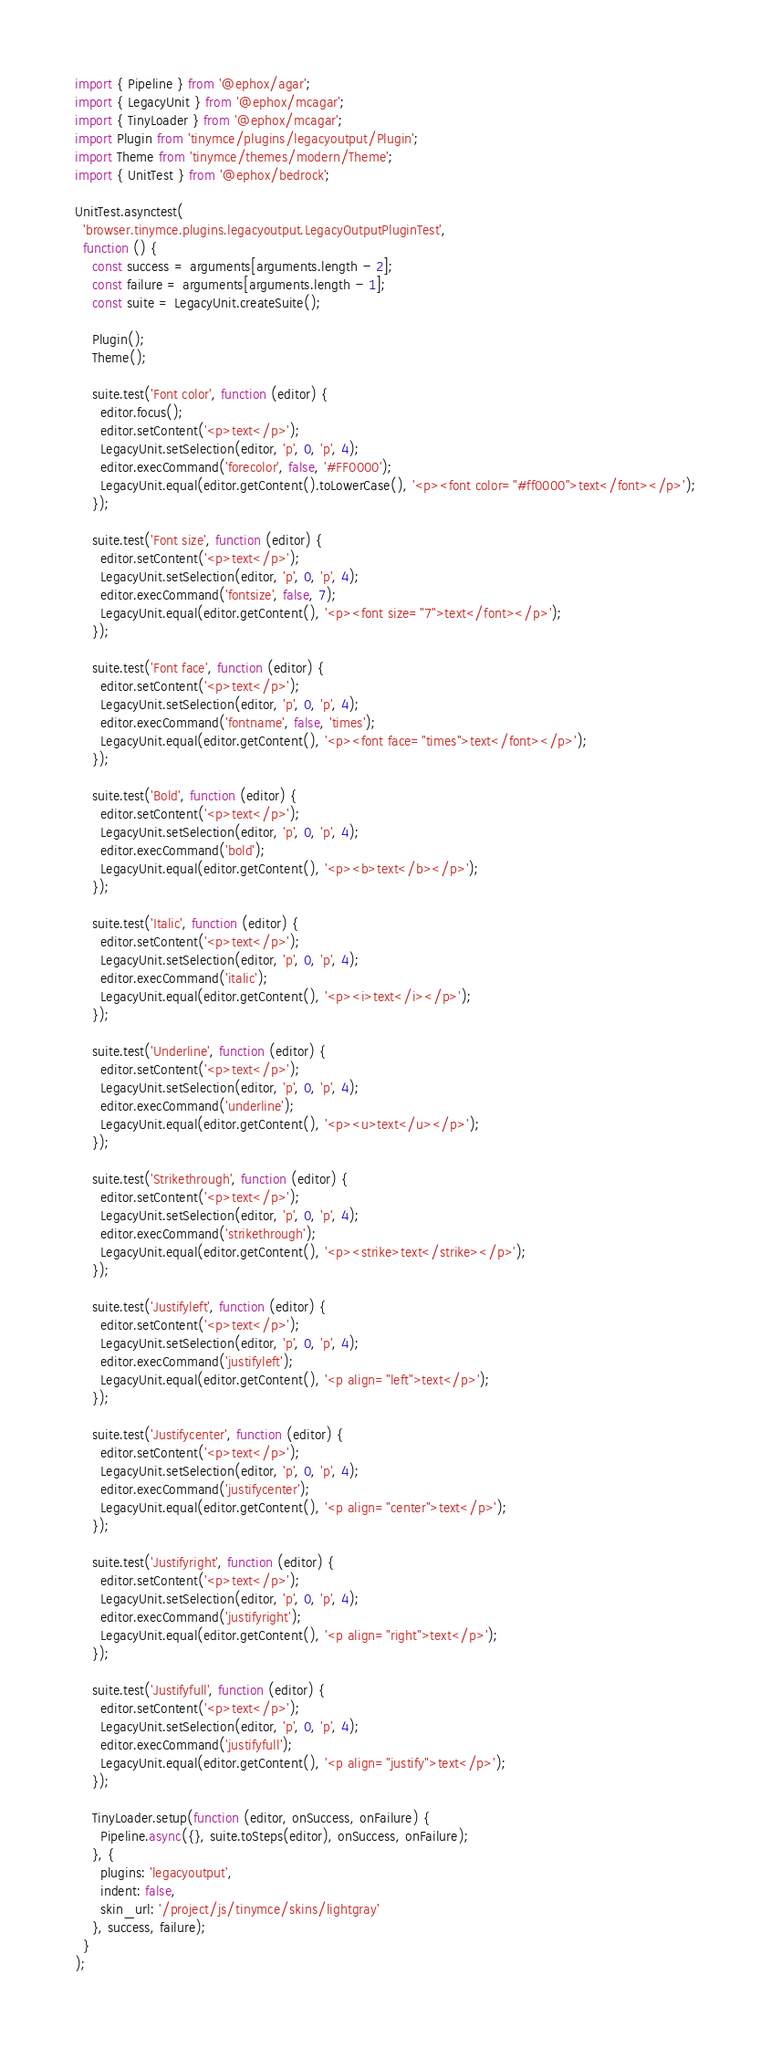Convert code to text. <code><loc_0><loc_0><loc_500><loc_500><_TypeScript_>import { Pipeline } from '@ephox/agar';
import { LegacyUnit } from '@ephox/mcagar';
import { TinyLoader } from '@ephox/mcagar';
import Plugin from 'tinymce/plugins/legacyoutput/Plugin';
import Theme from 'tinymce/themes/modern/Theme';
import { UnitTest } from '@ephox/bedrock';

UnitTest.asynctest(
  'browser.tinymce.plugins.legacyoutput.LegacyOutputPluginTest',
  function () {
    const success = arguments[arguments.length - 2];
    const failure = arguments[arguments.length - 1];
    const suite = LegacyUnit.createSuite();

    Plugin();
    Theme();

    suite.test('Font color', function (editor) {
      editor.focus();
      editor.setContent('<p>text</p>');
      LegacyUnit.setSelection(editor, 'p', 0, 'p', 4);
      editor.execCommand('forecolor', false, '#FF0000');
      LegacyUnit.equal(editor.getContent().toLowerCase(), '<p><font color="#ff0000">text</font></p>');
    });

    suite.test('Font size', function (editor) {
      editor.setContent('<p>text</p>');
      LegacyUnit.setSelection(editor, 'p', 0, 'p', 4);
      editor.execCommand('fontsize', false, 7);
      LegacyUnit.equal(editor.getContent(), '<p><font size="7">text</font></p>');
    });

    suite.test('Font face', function (editor) {
      editor.setContent('<p>text</p>');
      LegacyUnit.setSelection(editor, 'p', 0, 'p', 4);
      editor.execCommand('fontname', false, 'times');
      LegacyUnit.equal(editor.getContent(), '<p><font face="times">text</font></p>');
    });

    suite.test('Bold', function (editor) {
      editor.setContent('<p>text</p>');
      LegacyUnit.setSelection(editor, 'p', 0, 'p', 4);
      editor.execCommand('bold');
      LegacyUnit.equal(editor.getContent(), '<p><b>text</b></p>');
    });

    suite.test('Italic', function (editor) {
      editor.setContent('<p>text</p>');
      LegacyUnit.setSelection(editor, 'p', 0, 'p', 4);
      editor.execCommand('italic');
      LegacyUnit.equal(editor.getContent(), '<p><i>text</i></p>');
    });

    suite.test('Underline', function (editor) {
      editor.setContent('<p>text</p>');
      LegacyUnit.setSelection(editor, 'p', 0, 'p', 4);
      editor.execCommand('underline');
      LegacyUnit.equal(editor.getContent(), '<p><u>text</u></p>');
    });

    suite.test('Strikethrough', function (editor) {
      editor.setContent('<p>text</p>');
      LegacyUnit.setSelection(editor, 'p', 0, 'p', 4);
      editor.execCommand('strikethrough');
      LegacyUnit.equal(editor.getContent(), '<p><strike>text</strike></p>');
    });

    suite.test('Justifyleft', function (editor) {
      editor.setContent('<p>text</p>');
      LegacyUnit.setSelection(editor, 'p', 0, 'p', 4);
      editor.execCommand('justifyleft');
      LegacyUnit.equal(editor.getContent(), '<p align="left">text</p>');
    });

    suite.test('Justifycenter', function (editor) {
      editor.setContent('<p>text</p>');
      LegacyUnit.setSelection(editor, 'p', 0, 'p', 4);
      editor.execCommand('justifycenter');
      LegacyUnit.equal(editor.getContent(), '<p align="center">text</p>');
    });

    suite.test('Justifyright', function (editor) {
      editor.setContent('<p>text</p>');
      LegacyUnit.setSelection(editor, 'p', 0, 'p', 4);
      editor.execCommand('justifyright');
      LegacyUnit.equal(editor.getContent(), '<p align="right">text</p>');
    });

    suite.test('Justifyfull', function (editor) {
      editor.setContent('<p>text</p>');
      LegacyUnit.setSelection(editor, 'p', 0, 'p', 4);
      editor.execCommand('justifyfull');
      LegacyUnit.equal(editor.getContent(), '<p align="justify">text</p>');
    });

    TinyLoader.setup(function (editor, onSuccess, onFailure) {
      Pipeline.async({}, suite.toSteps(editor), onSuccess, onFailure);
    }, {
      plugins: 'legacyoutput',
      indent: false,
      skin_url: '/project/js/tinymce/skins/lightgray'
    }, success, failure);
  }
);
</code> 